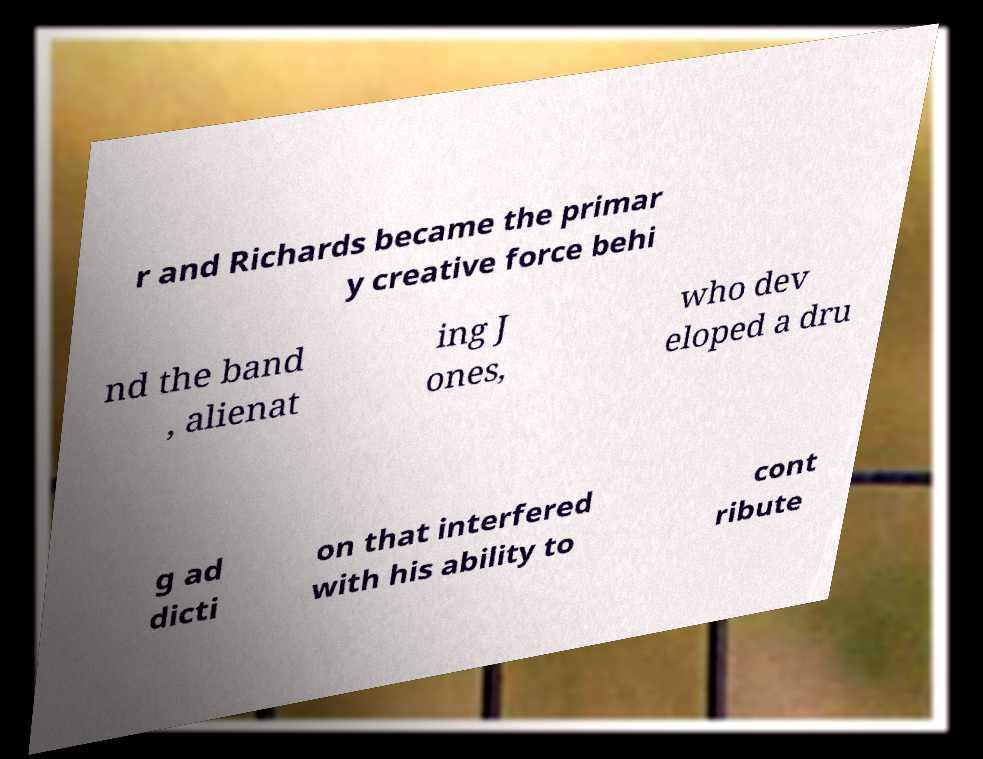Please identify and transcribe the text found in this image. r and Richards became the primar y creative force behi nd the band , alienat ing J ones, who dev eloped a dru g ad dicti on that interfered with his ability to cont ribute 